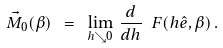Convert formula to latex. <formula><loc_0><loc_0><loc_500><loc_500>\vec { M } _ { 0 } ( \beta ) \ = \ \lim _ { h \searrow 0 } \, \frac { d } { d h } \ F ( h \hat { e } , \beta ) \, .</formula> 